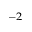<formula> <loc_0><loc_0><loc_500><loc_500>^ { - 2 }</formula> 